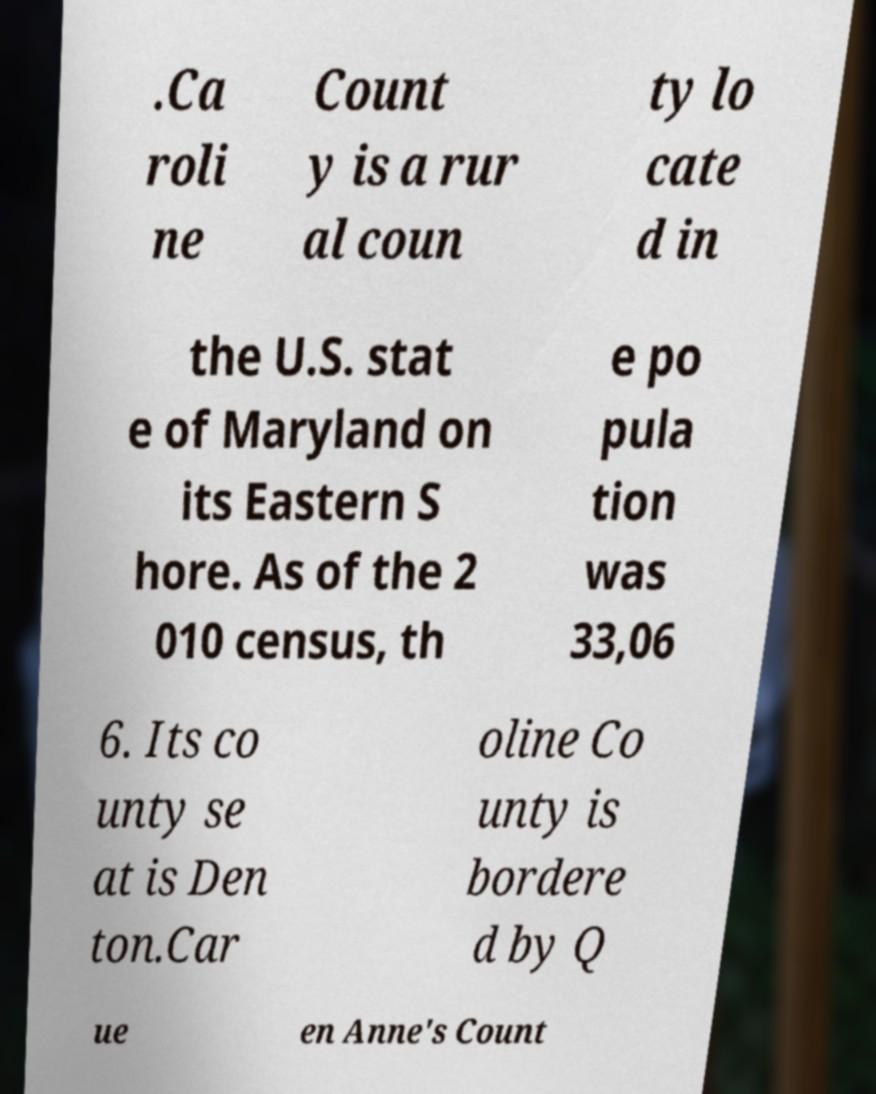What messages or text are displayed in this image? I need them in a readable, typed format. .Ca roli ne Count y is a rur al coun ty lo cate d in the U.S. stat e of Maryland on its Eastern S hore. As of the 2 010 census, th e po pula tion was 33,06 6. Its co unty se at is Den ton.Car oline Co unty is bordere d by Q ue en Anne's Count 